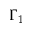Convert formula to latex. <formula><loc_0><loc_0><loc_500><loc_500>\Gamma _ { 1 }</formula> 